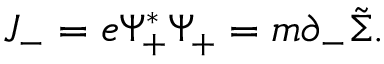<formula> <loc_0><loc_0><loc_500><loc_500>J _ { - } = e { \Psi } _ { + } ^ { \ast } { \Psi } _ { + } = m { \partial } _ { - } \tilde { \Sigma } .</formula> 